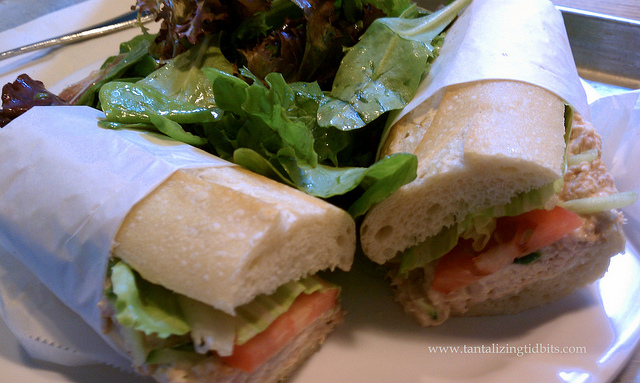Identify and read out the text in this image. www.tantalizingtidbits.com 